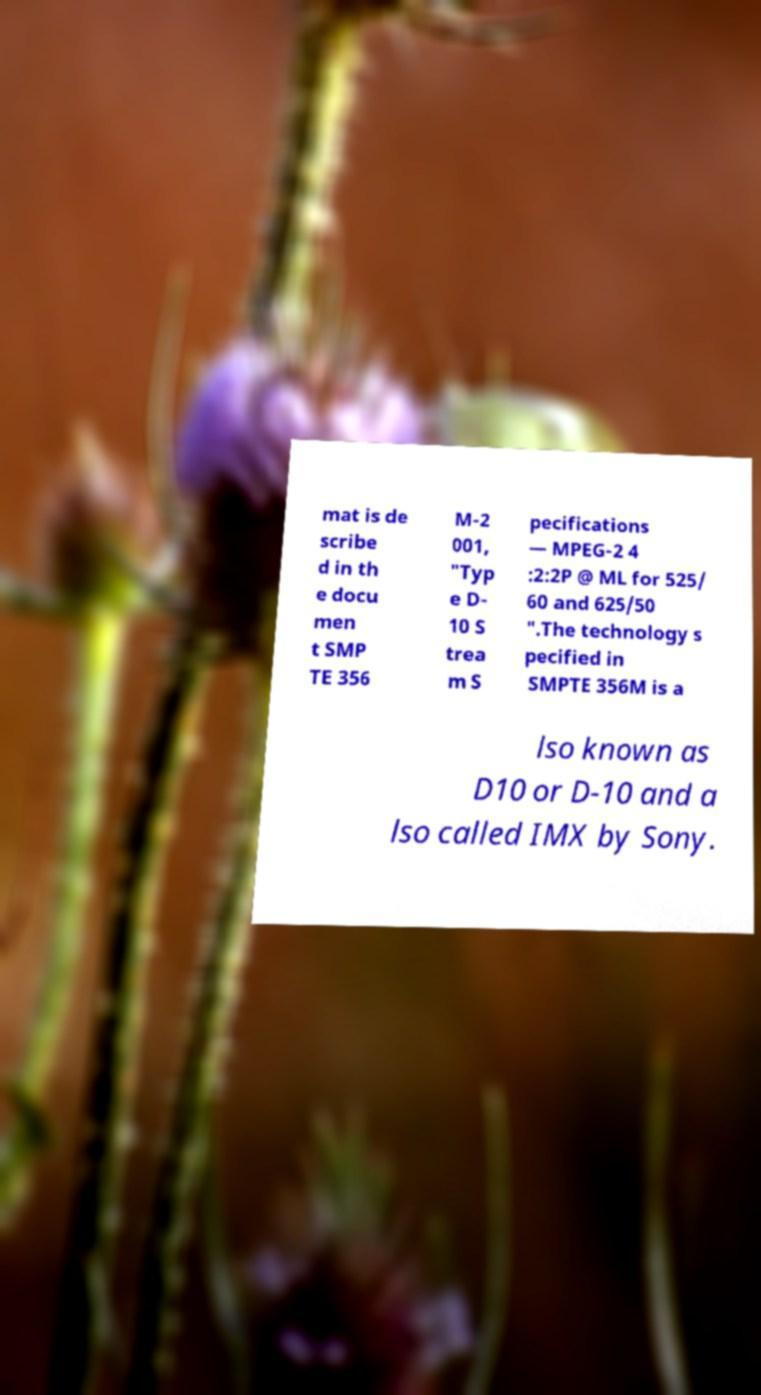Could you assist in decoding the text presented in this image and type it out clearly? mat is de scribe d in th e docu men t SMP TE 356 M-2 001, "Typ e D- 10 S trea m S pecifications — MPEG-2 4 :2:2P @ ML for 525/ 60 and 625/50 ".The technology s pecified in SMPTE 356M is a lso known as D10 or D-10 and a lso called IMX by Sony. 